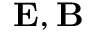Convert formula to latex. <formula><loc_0><loc_0><loc_500><loc_500>E , B</formula> 